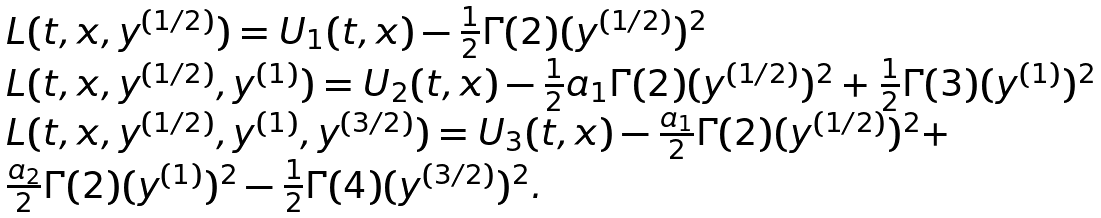<formula> <loc_0><loc_0><loc_500><loc_500>\begin{array} { l } { L ( t , x , y ^ { ( 1 / 2 ) } ) = U _ { 1 } ( t , x ) - \frac { 1 } { 2 } \Gamma ( 2 ) ( y ^ { ( 1 / 2 ) } ) ^ { 2 } } \\ { L ( t , x , y ^ { ( 1 / 2 ) } , y ^ { ( 1 ) } ) = U _ { 2 } ( t , x ) - \frac { 1 } { 2 } a _ { 1 } \Gamma ( 2 ) ( y ^ { ( 1 / 2 ) } ) ^ { 2 } + \frac { 1 } { 2 } \Gamma ( 3 ) ( y ^ { ( 1 ) } ) ^ { 2 } } \\ { L ( t , x , y ^ { ( 1 / 2 ) } , y ^ { ( 1 ) } , y ^ { ( 3 / 2 ) } ) = U _ { 3 } ( t , x ) - \frac { a _ { 1 } } { 2 } \Gamma ( 2 ) ( y ^ { ( 1 / 2 ) } ) ^ { 2 } + } \\ { \frac { a _ { 2 } } { 2 } \Gamma ( 2 ) ( y ^ { ( 1 ) } ) ^ { 2 } - \frac { 1 } { 2 } \Gamma ( 4 ) ( y ^ { ( 3 / 2 ) } ) ^ { 2 } . } \end{array}</formula> 